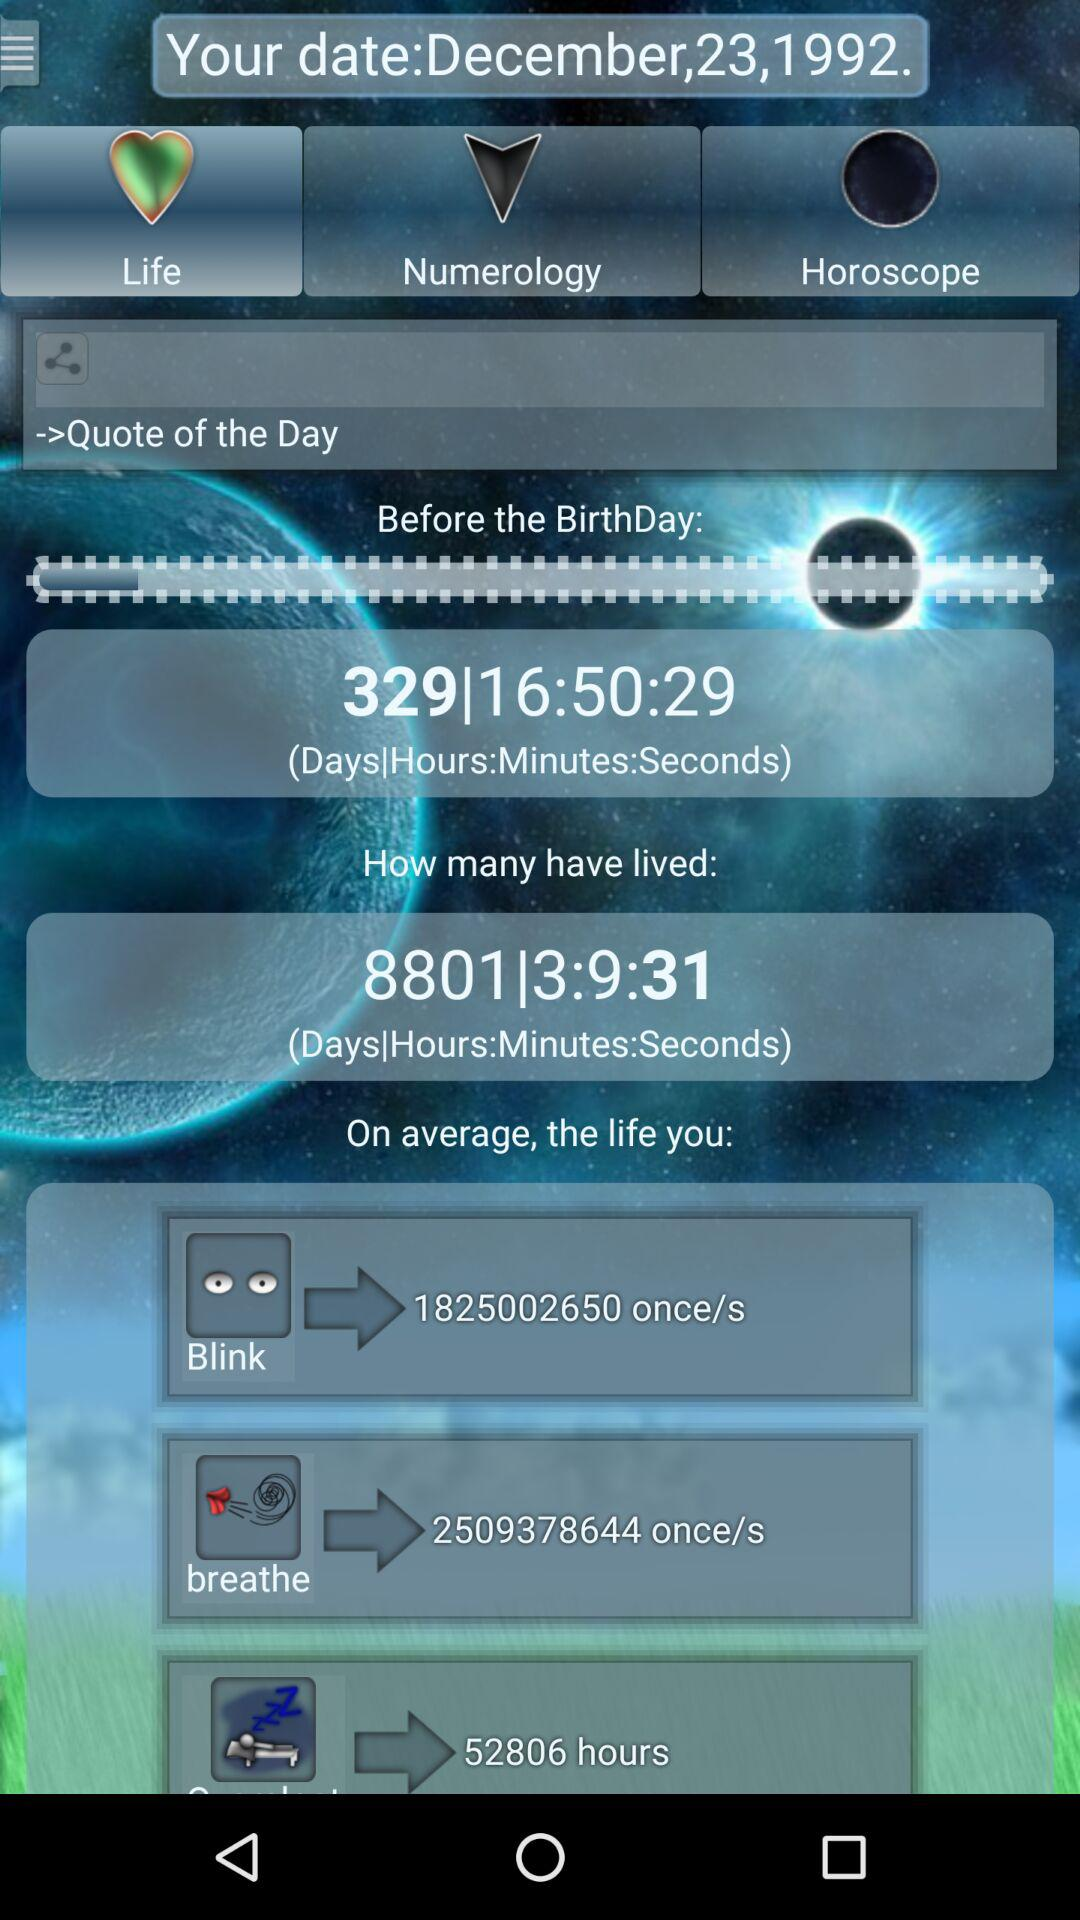What is the mentioned date? The mentioned date is December 23, 1992. 